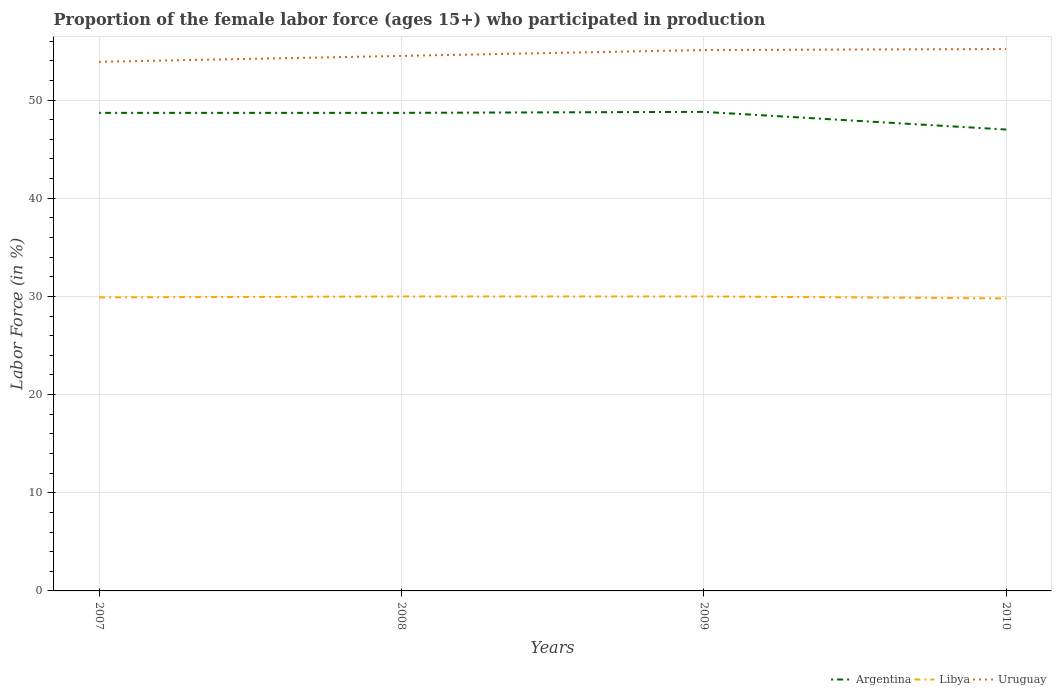How many different coloured lines are there?
Make the answer very short. 3. Does the line corresponding to Uruguay intersect with the line corresponding to Libya?
Make the answer very short. No. Is the number of lines equal to the number of legend labels?
Offer a terse response. Yes. Across all years, what is the maximum proportion of the female labor force who participated in production in Argentina?
Provide a succinct answer. 47. What is the total proportion of the female labor force who participated in production in Libya in the graph?
Give a very brief answer. 0. What is the difference between the highest and the second highest proportion of the female labor force who participated in production in Argentina?
Ensure brevity in your answer.  1.8. How many years are there in the graph?
Your response must be concise. 4. What is the difference between two consecutive major ticks on the Y-axis?
Make the answer very short. 10. Does the graph contain any zero values?
Your answer should be compact. No. How are the legend labels stacked?
Offer a terse response. Horizontal. What is the title of the graph?
Offer a very short reply. Proportion of the female labor force (ages 15+) who participated in production. What is the label or title of the Y-axis?
Ensure brevity in your answer.  Labor Force (in %). What is the Labor Force (in %) in Argentina in 2007?
Offer a very short reply. 48.7. What is the Labor Force (in %) of Libya in 2007?
Provide a short and direct response. 29.9. What is the Labor Force (in %) in Uruguay in 2007?
Provide a succinct answer. 53.9. What is the Labor Force (in %) of Argentina in 2008?
Ensure brevity in your answer.  48.7. What is the Labor Force (in %) in Libya in 2008?
Provide a succinct answer. 30. What is the Labor Force (in %) in Uruguay in 2008?
Provide a succinct answer. 54.5. What is the Labor Force (in %) in Argentina in 2009?
Your response must be concise. 48.8. What is the Labor Force (in %) of Libya in 2009?
Make the answer very short. 30. What is the Labor Force (in %) in Uruguay in 2009?
Offer a very short reply. 55.1. What is the Labor Force (in %) of Argentina in 2010?
Give a very brief answer. 47. What is the Labor Force (in %) in Libya in 2010?
Offer a very short reply. 29.8. What is the Labor Force (in %) of Uruguay in 2010?
Offer a very short reply. 55.2. Across all years, what is the maximum Labor Force (in %) of Argentina?
Give a very brief answer. 48.8. Across all years, what is the maximum Labor Force (in %) in Libya?
Give a very brief answer. 30. Across all years, what is the maximum Labor Force (in %) of Uruguay?
Give a very brief answer. 55.2. Across all years, what is the minimum Labor Force (in %) in Libya?
Your answer should be compact. 29.8. Across all years, what is the minimum Labor Force (in %) in Uruguay?
Ensure brevity in your answer.  53.9. What is the total Labor Force (in %) of Argentina in the graph?
Provide a succinct answer. 193.2. What is the total Labor Force (in %) of Libya in the graph?
Ensure brevity in your answer.  119.7. What is the total Labor Force (in %) of Uruguay in the graph?
Your answer should be very brief. 218.7. What is the difference between the Labor Force (in %) of Argentina in 2007 and that in 2008?
Make the answer very short. 0. What is the difference between the Labor Force (in %) of Libya in 2007 and that in 2008?
Provide a short and direct response. -0.1. What is the difference between the Labor Force (in %) in Uruguay in 2007 and that in 2008?
Offer a terse response. -0.6. What is the difference between the Labor Force (in %) in Argentina in 2007 and that in 2009?
Offer a very short reply. -0.1. What is the difference between the Labor Force (in %) in Libya in 2007 and that in 2009?
Your answer should be compact. -0.1. What is the difference between the Labor Force (in %) of Argentina in 2007 and that in 2010?
Give a very brief answer. 1.7. What is the difference between the Labor Force (in %) of Libya in 2008 and that in 2009?
Make the answer very short. 0. What is the difference between the Labor Force (in %) in Argentina in 2008 and that in 2010?
Offer a terse response. 1.7. What is the difference between the Labor Force (in %) in Libya in 2008 and that in 2010?
Keep it short and to the point. 0.2. What is the difference between the Labor Force (in %) in Argentina in 2009 and that in 2010?
Keep it short and to the point. 1.8. What is the difference between the Labor Force (in %) of Libya in 2009 and that in 2010?
Offer a very short reply. 0.2. What is the difference between the Labor Force (in %) of Libya in 2007 and the Labor Force (in %) of Uruguay in 2008?
Your answer should be very brief. -24.6. What is the difference between the Labor Force (in %) in Argentina in 2007 and the Labor Force (in %) in Libya in 2009?
Give a very brief answer. 18.7. What is the difference between the Labor Force (in %) in Libya in 2007 and the Labor Force (in %) in Uruguay in 2009?
Make the answer very short. -25.2. What is the difference between the Labor Force (in %) of Argentina in 2007 and the Labor Force (in %) of Libya in 2010?
Your answer should be compact. 18.9. What is the difference between the Labor Force (in %) in Libya in 2007 and the Labor Force (in %) in Uruguay in 2010?
Keep it short and to the point. -25.3. What is the difference between the Labor Force (in %) of Argentina in 2008 and the Labor Force (in %) of Libya in 2009?
Give a very brief answer. 18.7. What is the difference between the Labor Force (in %) of Libya in 2008 and the Labor Force (in %) of Uruguay in 2009?
Your response must be concise. -25.1. What is the difference between the Labor Force (in %) of Argentina in 2008 and the Labor Force (in %) of Libya in 2010?
Give a very brief answer. 18.9. What is the difference between the Labor Force (in %) of Libya in 2008 and the Labor Force (in %) of Uruguay in 2010?
Your answer should be compact. -25.2. What is the difference between the Labor Force (in %) of Libya in 2009 and the Labor Force (in %) of Uruguay in 2010?
Provide a short and direct response. -25.2. What is the average Labor Force (in %) in Argentina per year?
Provide a short and direct response. 48.3. What is the average Labor Force (in %) of Libya per year?
Your answer should be compact. 29.93. What is the average Labor Force (in %) in Uruguay per year?
Offer a very short reply. 54.67. In the year 2007, what is the difference between the Labor Force (in %) in Argentina and Labor Force (in %) in Libya?
Provide a short and direct response. 18.8. In the year 2008, what is the difference between the Labor Force (in %) in Argentina and Labor Force (in %) in Libya?
Your response must be concise. 18.7. In the year 2008, what is the difference between the Labor Force (in %) of Argentina and Labor Force (in %) of Uruguay?
Make the answer very short. -5.8. In the year 2008, what is the difference between the Labor Force (in %) in Libya and Labor Force (in %) in Uruguay?
Give a very brief answer. -24.5. In the year 2009, what is the difference between the Labor Force (in %) in Libya and Labor Force (in %) in Uruguay?
Keep it short and to the point. -25.1. In the year 2010, what is the difference between the Labor Force (in %) of Argentina and Labor Force (in %) of Uruguay?
Your response must be concise. -8.2. In the year 2010, what is the difference between the Labor Force (in %) of Libya and Labor Force (in %) of Uruguay?
Offer a terse response. -25.4. What is the ratio of the Labor Force (in %) of Libya in 2007 to that in 2008?
Ensure brevity in your answer.  1. What is the ratio of the Labor Force (in %) of Uruguay in 2007 to that in 2008?
Provide a succinct answer. 0.99. What is the ratio of the Labor Force (in %) in Argentina in 2007 to that in 2009?
Ensure brevity in your answer.  1. What is the ratio of the Labor Force (in %) of Uruguay in 2007 to that in 2009?
Give a very brief answer. 0.98. What is the ratio of the Labor Force (in %) of Argentina in 2007 to that in 2010?
Your answer should be very brief. 1.04. What is the ratio of the Labor Force (in %) in Uruguay in 2007 to that in 2010?
Give a very brief answer. 0.98. What is the ratio of the Labor Force (in %) in Argentina in 2008 to that in 2009?
Provide a succinct answer. 1. What is the ratio of the Labor Force (in %) of Libya in 2008 to that in 2009?
Offer a terse response. 1. What is the ratio of the Labor Force (in %) of Uruguay in 2008 to that in 2009?
Provide a short and direct response. 0.99. What is the ratio of the Labor Force (in %) of Argentina in 2008 to that in 2010?
Ensure brevity in your answer.  1.04. What is the ratio of the Labor Force (in %) of Libya in 2008 to that in 2010?
Offer a very short reply. 1.01. What is the ratio of the Labor Force (in %) in Uruguay in 2008 to that in 2010?
Make the answer very short. 0.99. What is the ratio of the Labor Force (in %) of Argentina in 2009 to that in 2010?
Provide a short and direct response. 1.04. What is the difference between the highest and the lowest Labor Force (in %) in Libya?
Keep it short and to the point. 0.2. What is the difference between the highest and the lowest Labor Force (in %) of Uruguay?
Your answer should be very brief. 1.3. 